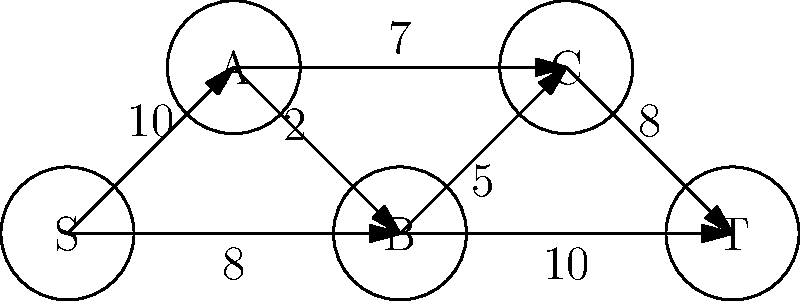Consider the pipeline system represented by the directed graph above, where S is the source and T is the sink. The numbers on the edges represent the maximum flow capacity (in million liters per hour) for each pipeline segment. Determine the maximum flow that can be achieved from S to T using the Ford-Fulkerson algorithm. Additionally, identify the minimum cut in this network. To solve this problem, we'll use the Ford-Fulkerson algorithm to find the maximum flow and identify the minimum cut:

1. Initialize flow to 0 for all edges.

2. Find augmenting paths from S to T:
   a) Path 1: S -> A -> C -> T (min capacity: 8)
      Update flow: 8
   b) Path 2: S -> B -> T (min capacity: 8)
      Update flow: 8 + 8 = 16
   c) Path 3: S -> A -> B -> T (min capacity: 2)
      Update flow: 16 + 2 = 18
   d) No more augmenting paths exist

3. The maximum flow is 18 million liters per hour.

4. To find the minimum cut:
   a) Mark all nodes reachable from S in the residual graph:
      S, A, and B are reachable
   b) The minimum cut consists of edges from marked to unmarked nodes:
      (A, C) with capacity 7
      (B, C) with capacity 5
      (B, T) with capacity 10

5. The capacity of the minimum cut is 7 + 5 + 10 = 22, which is equal to the sum of outgoing edges from S, confirming our maximum flow result.
Answer: Maximum flow: 18 million liters per hour. Minimum cut: {(A,C), (B,C), (B,T)}. 